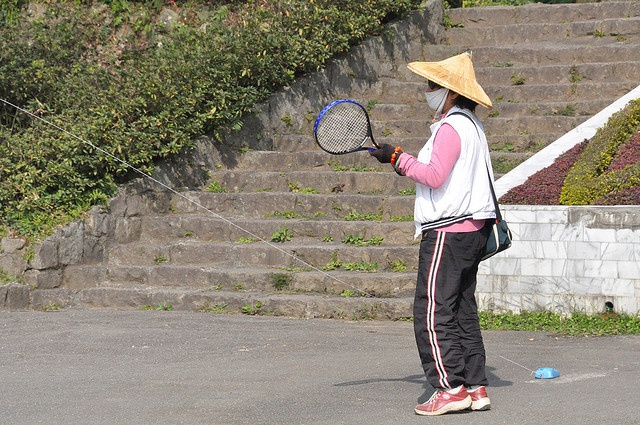Describe the objects in this image and their specific colors. I can see people in olive, white, black, gray, and lightpink tones, tennis racket in olive, darkgray, gray, lightgray, and black tones, and handbag in olive, black, gray, white, and purple tones in this image. 